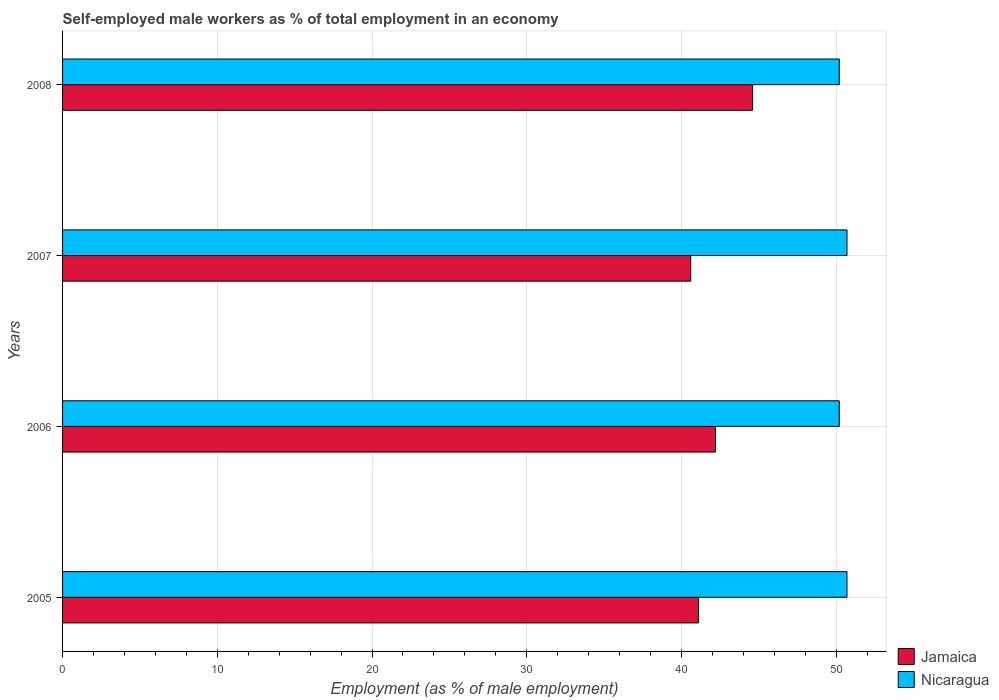Are the number of bars per tick equal to the number of legend labels?
Ensure brevity in your answer.  Yes. How many bars are there on the 4th tick from the bottom?
Your answer should be compact. 2. In how many cases, is the number of bars for a given year not equal to the number of legend labels?
Keep it short and to the point. 0. What is the percentage of self-employed male workers in Jamaica in 2005?
Your answer should be compact. 41.1. Across all years, what is the maximum percentage of self-employed male workers in Jamaica?
Give a very brief answer. 44.6. Across all years, what is the minimum percentage of self-employed male workers in Jamaica?
Offer a terse response. 40.6. In which year was the percentage of self-employed male workers in Nicaragua minimum?
Your response must be concise. 2006. What is the total percentage of self-employed male workers in Jamaica in the graph?
Your answer should be very brief. 168.5. What is the average percentage of self-employed male workers in Jamaica per year?
Your response must be concise. 42.12. In the year 2006, what is the difference between the percentage of self-employed male workers in Jamaica and percentage of self-employed male workers in Nicaragua?
Ensure brevity in your answer.  -8. In how many years, is the percentage of self-employed male workers in Nicaragua greater than 28 %?
Provide a succinct answer. 4. What is the ratio of the percentage of self-employed male workers in Nicaragua in 2006 to that in 2008?
Make the answer very short. 1. Is the percentage of self-employed male workers in Nicaragua in 2006 less than that in 2008?
Provide a short and direct response. No. Is the difference between the percentage of self-employed male workers in Jamaica in 2005 and 2008 greater than the difference between the percentage of self-employed male workers in Nicaragua in 2005 and 2008?
Your answer should be compact. No. What is the difference between the highest and the lowest percentage of self-employed male workers in Jamaica?
Your response must be concise. 4. In how many years, is the percentage of self-employed male workers in Nicaragua greater than the average percentage of self-employed male workers in Nicaragua taken over all years?
Keep it short and to the point. 2. Is the sum of the percentage of self-employed male workers in Jamaica in 2005 and 2008 greater than the maximum percentage of self-employed male workers in Nicaragua across all years?
Offer a terse response. Yes. What does the 1st bar from the top in 2006 represents?
Your response must be concise. Nicaragua. What does the 1st bar from the bottom in 2006 represents?
Offer a very short reply. Jamaica. What is the difference between two consecutive major ticks on the X-axis?
Your response must be concise. 10. Does the graph contain grids?
Give a very brief answer. Yes. How many legend labels are there?
Offer a terse response. 2. How are the legend labels stacked?
Keep it short and to the point. Vertical. What is the title of the graph?
Offer a terse response. Self-employed male workers as % of total employment in an economy. Does "Syrian Arab Republic" appear as one of the legend labels in the graph?
Keep it short and to the point. No. What is the label or title of the X-axis?
Provide a succinct answer. Employment (as % of male employment). What is the label or title of the Y-axis?
Your answer should be very brief. Years. What is the Employment (as % of male employment) in Jamaica in 2005?
Keep it short and to the point. 41.1. What is the Employment (as % of male employment) in Nicaragua in 2005?
Provide a short and direct response. 50.7. What is the Employment (as % of male employment) of Jamaica in 2006?
Make the answer very short. 42.2. What is the Employment (as % of male employment) in Nicaragua in 2006?
Your answer should be compact. 50.2. What is the Employment (as % of male employment) of Jamaica in 2007?
Offer a terse response. 40.6. What is the Employment (as % of male employment) in Nicaragua in 2007?
Your answer should be very brief. 50.7. What is the Employment (as % of male employment) in Jamaica in 2008?
Keep it short and to the point. 44.6. What is the Employment (as % of male employment) in Nicaragua in 2008?
Keep it short and to the point. 50.2. Across all years, what is the maximum Employment (as % of male employment) in Jamaica?
Provide a succinct answer. 44.6. Across all years, what is the maximum Employment (as % of male employment) in Nicaragua?
Your answer should be very brief. 50.7. Across all years, what is the minimum Employment (as % of male employment) of Jamaica?
Give a very brief answer. 40.6. Across all years, what is the minimum Employment (as % of male employment) of Nicaragua?
Provide a short and direct response. 50.2. What is the total Employment (as % of male employment) in Jamaica in the graph?
Offer a very short reply. 168.5. What is the total Employment (as % of male employment) in Nicaragua in the graph?
Your answer should be compact. 201.8. What is the difference between the Employment (as % of male employment) of Jamaica in 2005 and that in 2006?
Ensure brevity in your answer.  -1.1. What is the difference between the Employment (as % of male employment) of Nicaragua in 2005 and that in 2006?
Your answer should be very brief. 0.5. What is the difference between the Employment (as % of male employment) in Jamaica in 2006 and that in 2008?
Your answer should be very brief. -2.4. What is the difference between the Employment (as % of male employment) in Nicaragua in 2007 and that in 2008?
Provide a succinct answer. 0.5. What is the difference between the Employment (as % of male employment) in Jamaica in 2005 and the Employment (as % of male employment) in Nicaragua in 2006?
Give a very brief answer. -9.1. What is the difference between the Employment (as % of male employment) of Jamaica in 2006 and the Employment (as % of male employment) of Nicaragua in 2008?
Provide a succinct answer. -8. What is the difference between the Employment (as % of male employment) of Jamaica in 2007 and the Employment (as % of male employment) of Nicaragua in 2008?
Your answer should be compact. -9.6. What is the average Employment (as % of male employment) in Jamaica per year?
Your answer should be compact. 42.12. What is the average Employment (as % of male employment) in Nicaragua per year?
Offer a terse response. 50.45. In the year 2006, what is the difference between the Employment (as % of male employment) in Jamaica and Employment (as % of male employment) in Nicaragua?
Provide a succinct answer. -8. What is the ratio of the Employment (as % of male employment) in Jamaica in 2005 to that in 2006?
Provide a short and direct response. 0.97. What is the ratio of the Employment (as % of male employment) in Nicaragua in 2005 to that in 2006?
Your answer should be compact. 1.01. What is the ratio of the Employment (as % of male employment) of Jamaica in 2005 to that in 2007?
Make the answer very short. 1.01. What is the ratio of the Employment (as % of male employment) of Nicaragua in 2005 to that in 2007?
Your answer should be very brief. 1. What is the ratio of the Employment (as % of male employment) in Jamaica in 2005 to that in 2008?
Your answer should be compact. 0.92. What is the ratio of the Employment (as % of male employment) of Jamaica in 2006 to that in 2007?
Your response must be concise. 1.04. What is the ratio of the Employment (as % of male employment) in Nicaragua in 2006 to that in 2007?
Your answer should be very brief. 0.99. What is the ratio of the Employment (as % of male employment) in Jamaica in 2006 to that in 2008?
Provide a succinct answer. 0.95. What is the ratio of the Employment (as % of male employment) of Nicaragua in 2006 to that in 2008?
Your answer should be compact. 1. What is the ratio of the Employment (as % of male employment) in Jamaica in 2007 to that in 2008?
Ensure brevity in your answer.  0.91. 